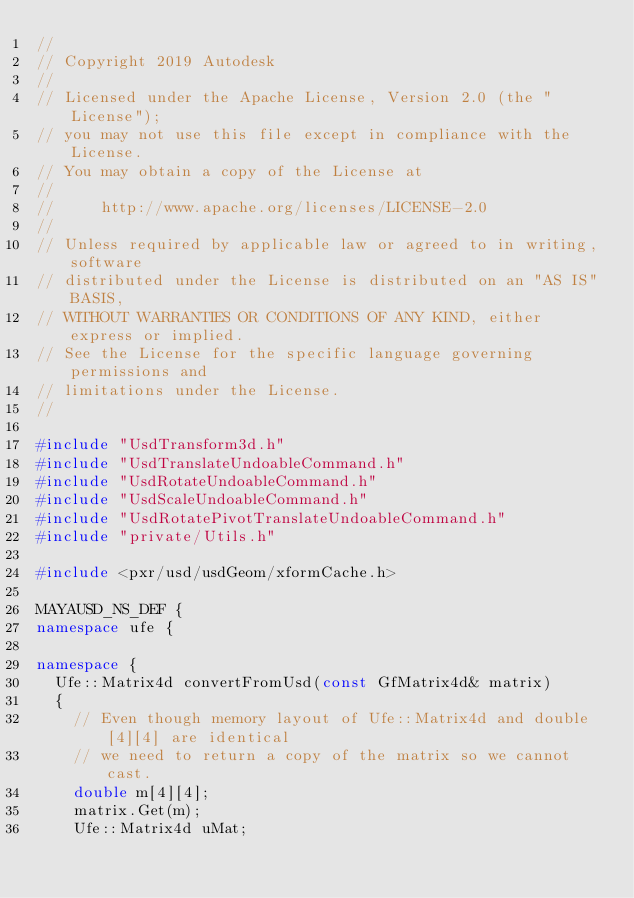Convert code to text. <code><loc_0><loc_0><loc_500><loc_500><_C++_>//
// Copyright 2019 Autodesk
//
// Licensed under the Apache License, Version 2.0 (the "License");
// you may not use this file except in compliance with the License.
// You may obtain a copy of the License at
//
//     http://www.apache.org/licenses/LICENSE-2.0
//
// Unless required by applicable law or agreed to in writing, software
// distributed under the License is distributed on an "AS IS" BASIS,
// WITHOUT WARRANTIES OR CONDITIONS OF ANY KIND, either express or implied.
// See the License for the specific language governing permissions and
// limitations under the License.
//

#include "UsdTransform3d.h"
#include "UsdTranslateUndoableCommand.h"
#include "UsdRotateUndoableCommand.h"
#include "UsdScaleUndoableCommand.h"
#include "UsdRotatePivotTranslateUndoableCommand.h"
#include "private/Utils.h"

#include <pxr/usd/usdGeom/xformCache.h>

MAYAUSD_NS_DEF {
namespace ufe {

namespace {
	Ufe::Matrix4d convertFromUsd(const GfMatrix4d& matrix)
	{
		// Even though memory layout of Ufe::Matrix4d and double[4][4] are identical
		// we need to return a copy of the matrix so we cannot cast.
		double m[4][4];
		matrix.Get(m);
		Ufe::Matrix4d uMat;</code> 